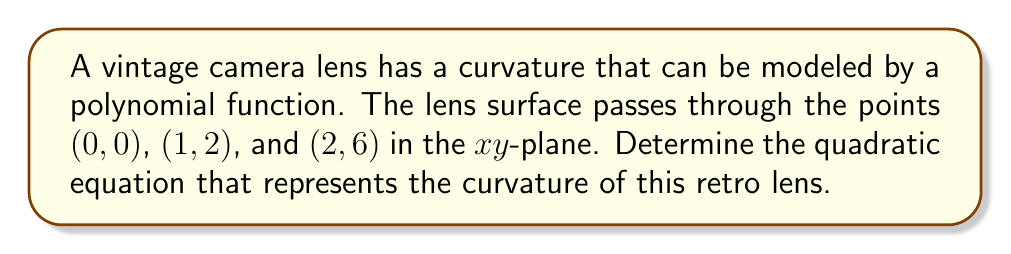Provide a solution to this math problem. Let's approach this step-by-step:

1) We know that a quadratic equation has the general form:
   $$f(x) = ax^2 + bx + c$$

2) We have three points that the curve passes through:
   (0, 0), (1, 2), and (2, 6)

3) Let's substitute these points into our general equation:
   For (0, 0): $0 = a(0)^2 + b(0) + c$, so $c = 0$
   For (1, 2): $2 = a(1)^2 + b(1) + 0$, so $2 = a + b$
   For (2, 6): $6 = a(2)^2 + b(2) + 0$, so $6 = 4a + 2b$

4) From step 3, we have two equations:
   $2 = a + b$
   $6 = 4a + 2b$

5) Multiply the first equation by 2:
   $4 = 2a + 2b$

6) Subtract this from the second equation:
   $6 - 4 = (4a + 2b) - (2a + 2b)$
   $2 = 2a$
   $a = 1$

7) Substitute this back into $2 = a + b$:
   $2 = 1 + b$
   $b = 1$

8) Therefore, our quadratic equation is:
   $$f(x) = x^2 + x$$

This equation represents the curvature of the vintage camera lens.
Answer: $f(x) = x^2 + x$ 